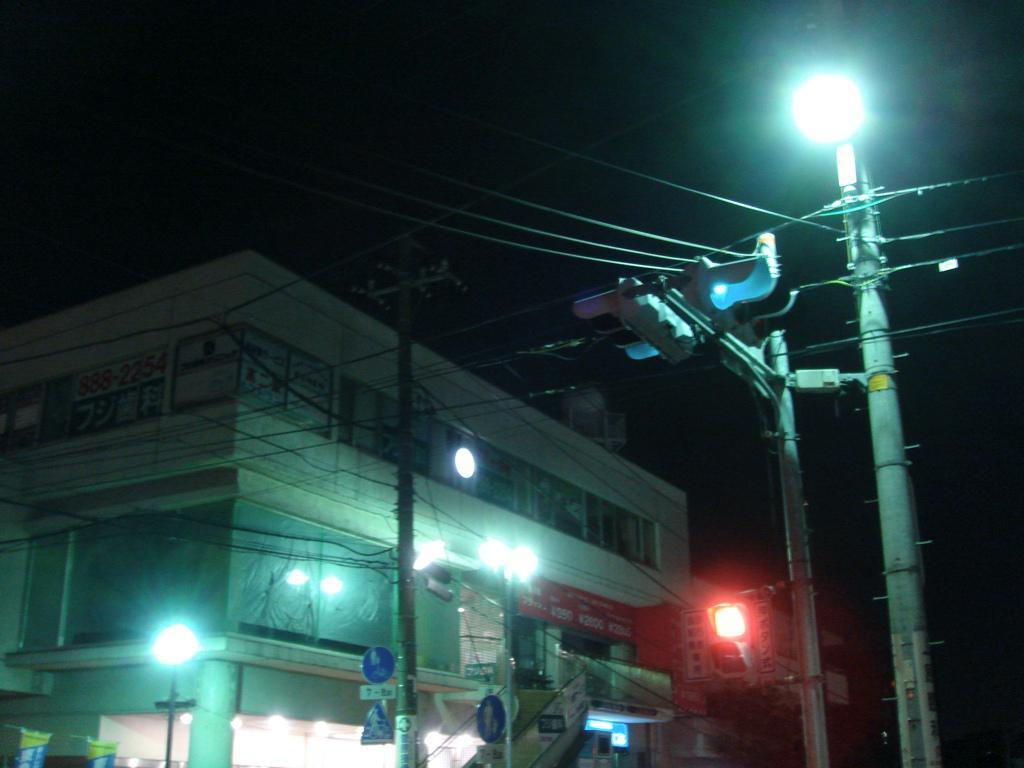What type of structures can be seen in the image? There are electric poles and buildings with text in the image. What else is present in the image besides the structures? There are lights in the image. Where are the electric poles and buildings with text located in the image? They are on the left side of the image. How many ants can be seen crawling on the picture in the image? There are no ants present in the image, and there is no picture mentioned in the provided facts. 